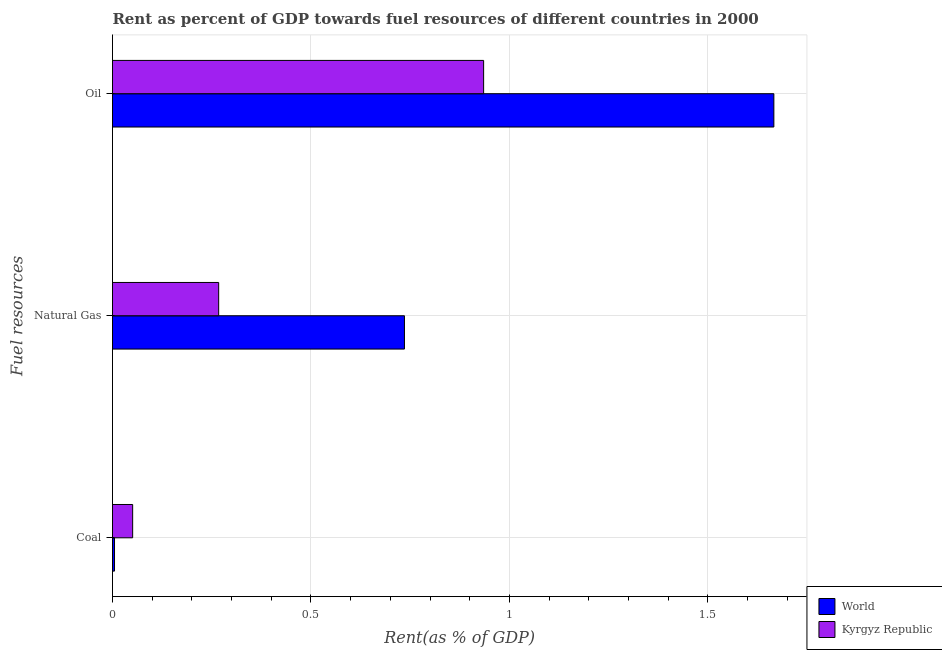How many groups of bars are there?
Make the answer very short. 3. How many bars are there on the 1st tick from the top?
Your answer should be very brief. 2. What is the label of the 2nd group of bars from the top?
Offer a very short reply. Natural Gas. What is the rent towards oil in Kyrgyz Republic?
Keep it short and to the point. 0.94. Across all countries, what is the maximum rent towards coal?
Your answer should be very brief. 0.05. Across all countries, what is the minimum rent towards coal?
Offer a very short reply. 0.01. In which country was the rent towards coal maximum?
Your answer should be compact. Kyrgyz Republic. In which country was the rent towards natural gas minimum?
Your answer should be very brief. Kyrgyz Republic. What is the total rent towards oil in the graph?
Offer a terse response. 2.6. What is the difference between the rent towards oil in World and that in Kyrgyz Republic?
Ensure brevity in your answer.  0.73. What is the difference between the rent towards natural gas in World and the rent towards oil in Kyrgyz Republic?
Your answer should be compact. -0.2. What is the average rent towards coal per country?
Offer a very short reply. 0.03. What is the difference between the rent towards coal and rent towards natural gas in Kyrgyz Republic?
Offer a very short reply. -0.22. In how many countries, is the rent towards oil greater than 1 %?
Give a very brief answer. 1. What is the ratio of the rent towards coal in World to that in Kyrgyz Republic?
Your answer should be compact. 0.1. Is the rent towards natural gas in World less than that in Kyrgyz Republic?
Your response must be concise. No. What is the difference between the highest and the second highest rent towards natural gas?
Offer a terse response. 0.47. What is the difference between the highest and the lowest rent towards coal?
Your answer should be compact. 0.05. In how many countries, is the rent towards oil greater than the average rent towards oil taken over all countries?
Give a very brief answer. 1. Is the sum of the rent towards oil in Kyrgyz Republic and World greater than the maximum rent towards coal across all countries?
Ensure brevity in your answer.  Yes. What does the 1st bar from the top in Oil represents?
Your answer should be compact. Kyrgyz Republic. What does the 2nd bar from the bottom in Natural Gas represents?
Ensure brevity in your answer.  Kyrgyz Republic. Are all the bars in the graph horizontal?
Keep it short and to the point. Yes. How many countries are there in the graph?
Make the answer very short. 2. What is the difference between two consecutive major ticks on the X-axis?
Offer a terse response. 0.5. Are the values on the major ticks of X-axis written in scientific E-notation?
Keep it short and to the point. No. Does the graph contain any zero values?
Provide a short and direct response. No. How many legend labels are there?
Give a very brief answer. 2. How are the legend labels stacked?
Provide a short and direct response. Vertical. What is the title of the graph?
Your answer should be compact. Rent as percent of GDP towards fuel resources of different countries in 2000. What is the label or title of the X-axis?
Your answer should be very brief. Rent(as % of GDP). What is the label or title of the Y-axis?
Ensure brevity in your answer.  Fuel resources. What is the Rent(as % of GDP) in World in Coal?
Give a very brief answer. 0.01. What is the Rent(as % of GDP) in Kyrgyz Republic in Coal?
Provide a succinct answer. 0.05. What is the Rent(as % of GDP) of World in Natural Gas?
Offer a very short reply. 0.74. What is the Rent(as % of GDP) in Kyrgyz Republic in Natural Gas?
Your answer should be very brief. 0.27. What is the Rent(as % of GDP) in World in Oil?
Offer a terse response. 1.67. What is the Rent(as % of GDP) of Kyrgyz Republic in Oil?
Provide a succinct answer. 0.94. Across all Fuel resources, what is the maximum Rent(as % of GDP) of World?
Your answer should be compact. 1.67. Across all Fuel resources, what is the maximum Rent(as % of GDP) of Kyrgyz Republic?
Keep it short and to the point. 0.94. Across all Fuel resources, what is the minimum Rent(as % of GDP) of World?
Your response must be concise. 0.01. Across all Fuel resources, what is the minimum Rent(as % of GDP) of Kyrgyz Republic?
Offer a very short reply. 0.05. What is the total Rent(as % of GDP) of World in the graph?
Offer a very short reply. 2.41. What is the total Rent(as % of GDP) of Kyrgyz Republic in the graph?
Provide a succinct answer. 1.25. What is the difference between the Rent(as % of GDP) of World in Coal and that in Natural Gas?
Your answer should be compact. -0.73. What is the difference between the Rent(as % of GDP) of Kyrgyz Republic in Coal and that in Natural Gas?
Make the answer very short. -0.22. What is the difference between the Rent(as % of GDP) of World in Coal and that in Oil?
Ensure brevity in your answer.  -1.66. What is the difference between the Rent(as % of GDP) in Kyrgyz Republic in Coal and that in Oil?
Your answer should be very brief. -0.88. What is the difference between the Rent(as % of GDP) in World in Natural Gas and that in Oil?
Offer a very short reply. -0.93. What is the difference between the Rent(as % of GDP) of Kyrgyz Republic in Natural Gas and that in Oil?
Provide a short and direct response. -0.67. What is the difference between the Rent(as % of GDP) of World in Coal and the Rent(as % of GDP) of Kyrgyz Republic in Natural Gas?
Ensure brevity in your answer.  -0.26. What is the difference between the Rent(as % of GDP) of World in Coal and the Rent(as % of GDP) of Kyrgyz Republic in Oil?
Your response must be concise. -0.93. What is the difference between the Rent(as % of GDP) of World in Natural Gas and the Rent(as % of GDP) of Kyrgyz Republic in Oil?
Provide a short and direct response. -0.2. What is the average Rent(as % of GDP) in World per Fuel resources?
Provide a short and direct response. 0.8. What is the average Rent(as % of GDP) in Kyrgyz Republic per Fuel resources?
Make the answer very short. 0.42. What is the difference between the Rent(as % of GDP) of World and Rent(as % of GDP) of Kyrgyz Republic in Coal?
Your response must be concise. -0.05. What is the difference between the Rent(as % of GDP) of World and Rent(as % of GDP) of Kyrgyz Republic in Natural Gas?
Your answer should be very brief. 0.47. What is the difference between the Rent(as % of GDP) of World and Rent(as % of GDP) of Kyrgyz Republic in Oil?
Offer a very short reply. 0.73. What is the ratio of the Rent(as % of GDP) of World in Coal to that in Natural Gas?
Give a very brief answer. 0.01. What is the ratio of the Rent(as % of GDP) in Kyrgyz Republic in Coal to that in Natural Gas?
Keep it short and to the point. 0.19. What is the ratio of the Rent(as % of GDP) of World in Coal to that in Oil?
Your answer should be compact. 0. What is the ratio of the Rent(as % of GDP) in Kyrgyz Republic in Coal to that in Oil?
Your answer should be very brief. 0.05. What is the ratio of the Rent(as % of GDP) of World in Natural Gas to that in Oil?
Ensure brevity in your answer.  0.44. What is the ratio of the Rent(as % of GDP) in Kyrgyz Republic in Natural Gas to that in Oil?
Make the answer very short. 0.29. What is the difference between the highest and the second highest Rent(as % of GDP) in World?
Your answer should be compact. 0.93. What is the difference between the highest and the second highest Rent(as % of GDP) in Kyrgyz Republic?
Provide a succinct answer. 0.67. What is the difference between the highest and the lowest Rent(as % of GDP) in World?
Provide a short and direct response. 1.66. What is the difference between the highest and the lowest Rent(as % of GDP) of Kyrgyz Republic?
Provide a succinct answer. 0.88. 